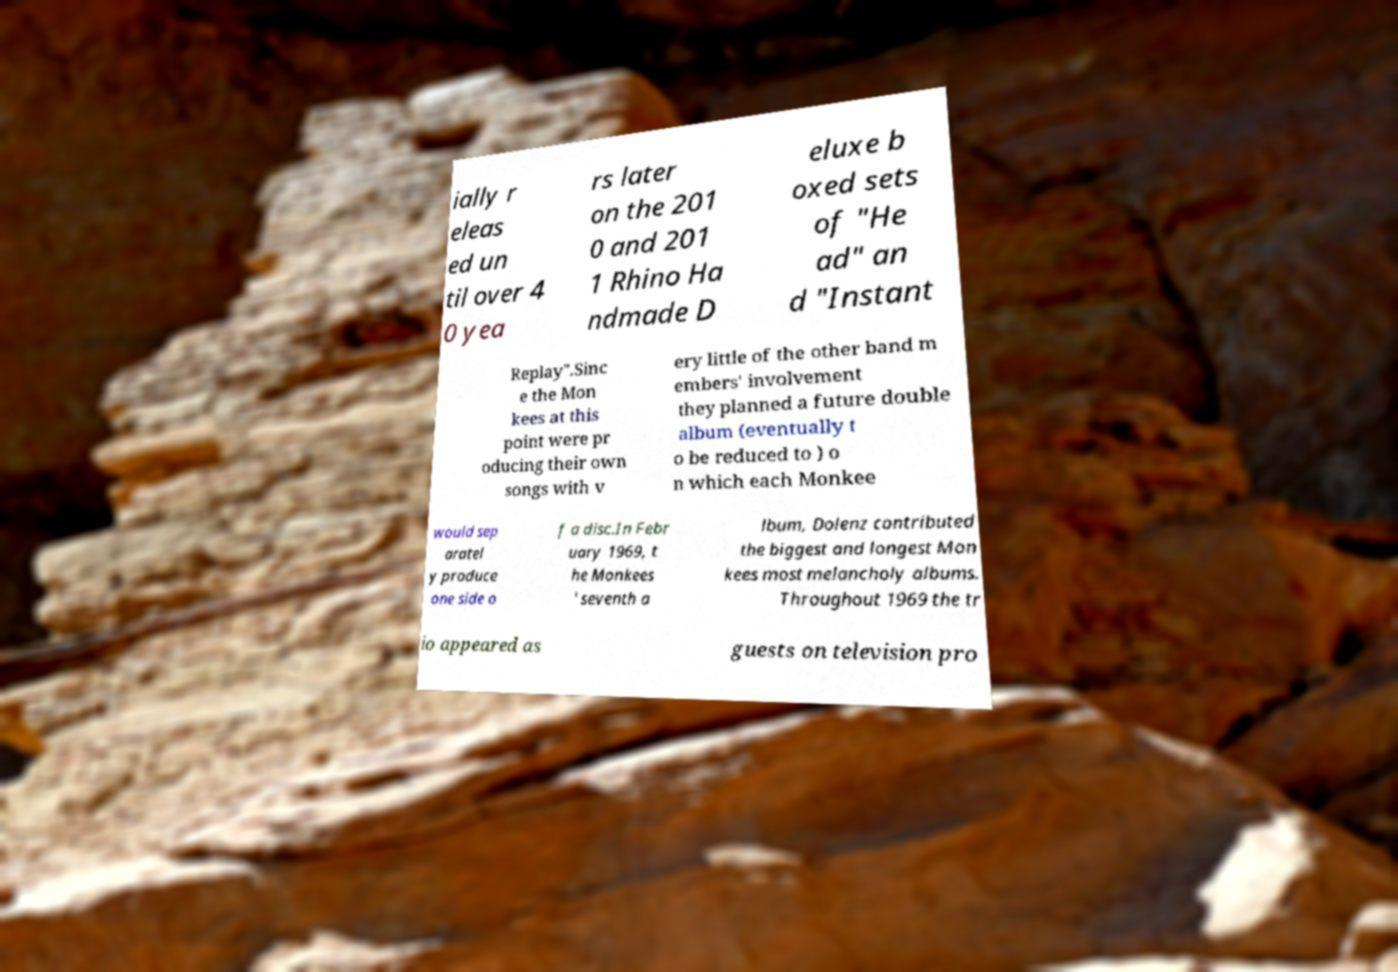For documentation purposes, I need the text within this image transcribed. Could you provide that? ially r eleas ed un til over 4 0 yea rs later on the 201 0 and 201 1 Rhino Ha ndmade D eluxe b oxed sets of "He ad" an d "Instant Replay".Sinc e the Mon kees at this point were pr oducing their own songs with v ery little of the other band m embers' involvement they planned a future double album (eventually t o be reduced to ) o n which each Monkee would sep aratel y produce one side o f a disc.In Febr uary 1969, t he Monkees ' seventh a lbum, Dolenz contributed the biggest and longest Mon kees most melancholy albums. Throughout 1969 the tr io appeared as guests on television pro 